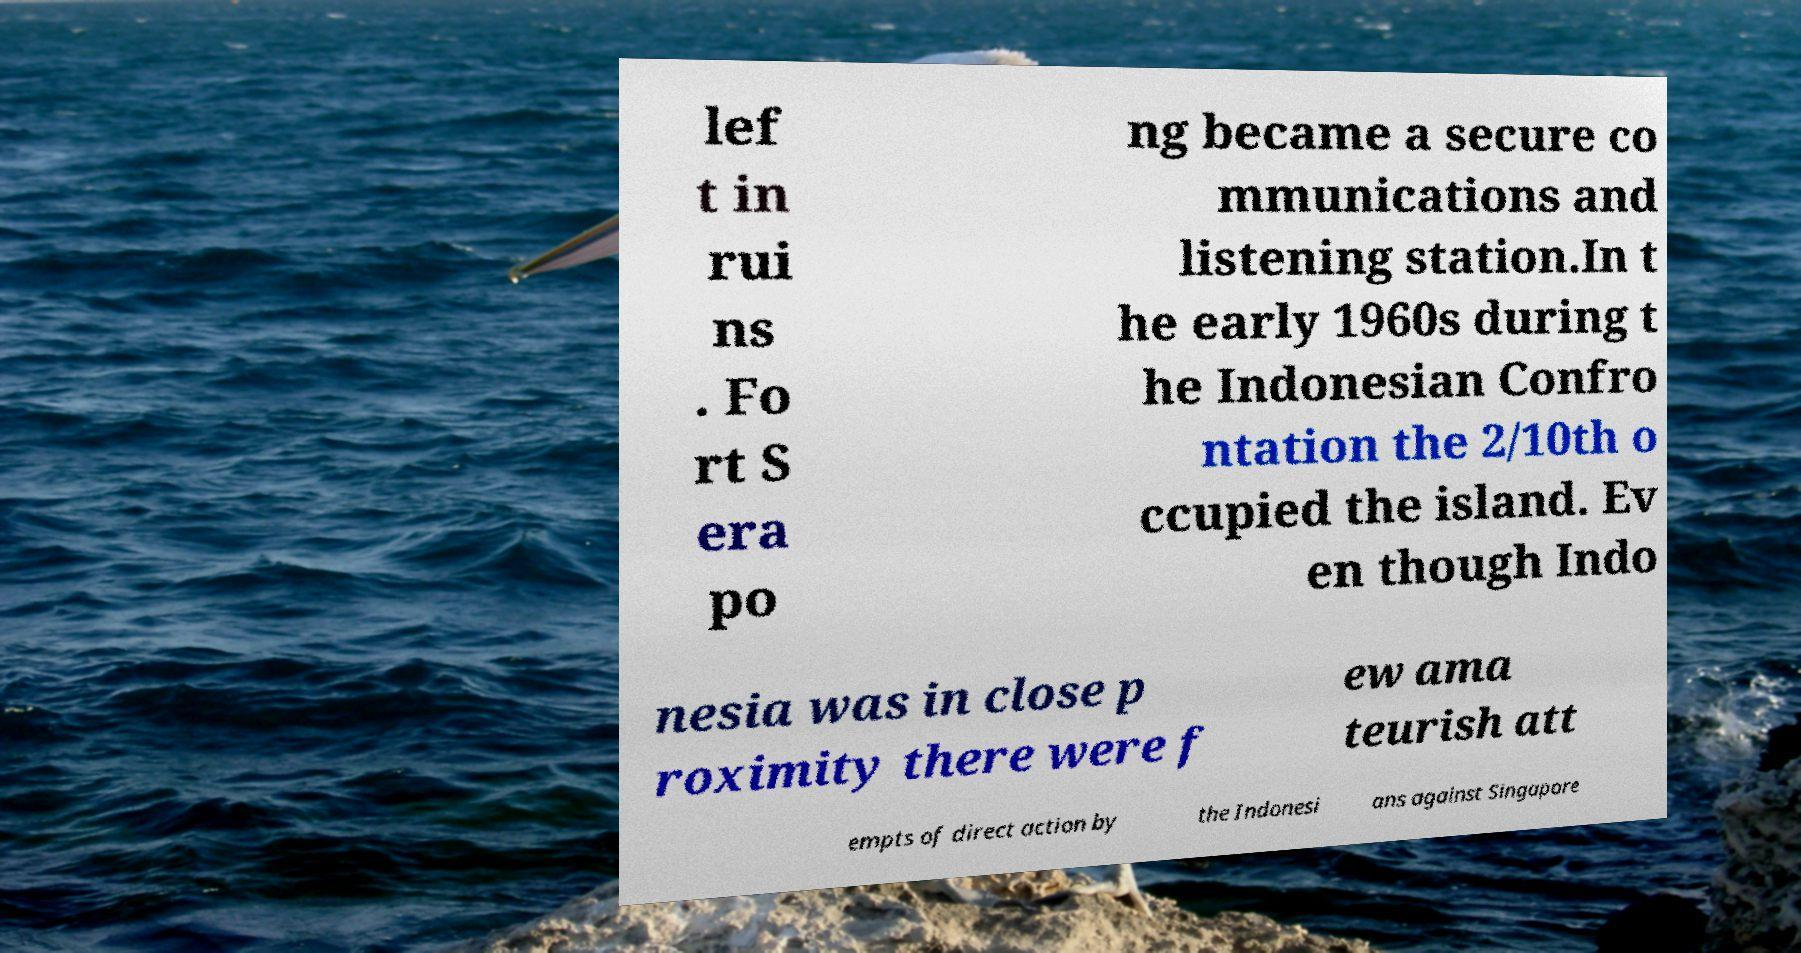Please read and relay the text visible in this image. What does it say? lef t in rui ns . Fo rt S era po ng became a secure co mmunications and listening station.In t he early 1960s during t he Indonesian Confro ntation the 2/10th o ccupied the island. Ev en though Indo nesia was in close p roximity there were f ew ama teurish att empts of direct action by the Indonesi ans against Singapore 